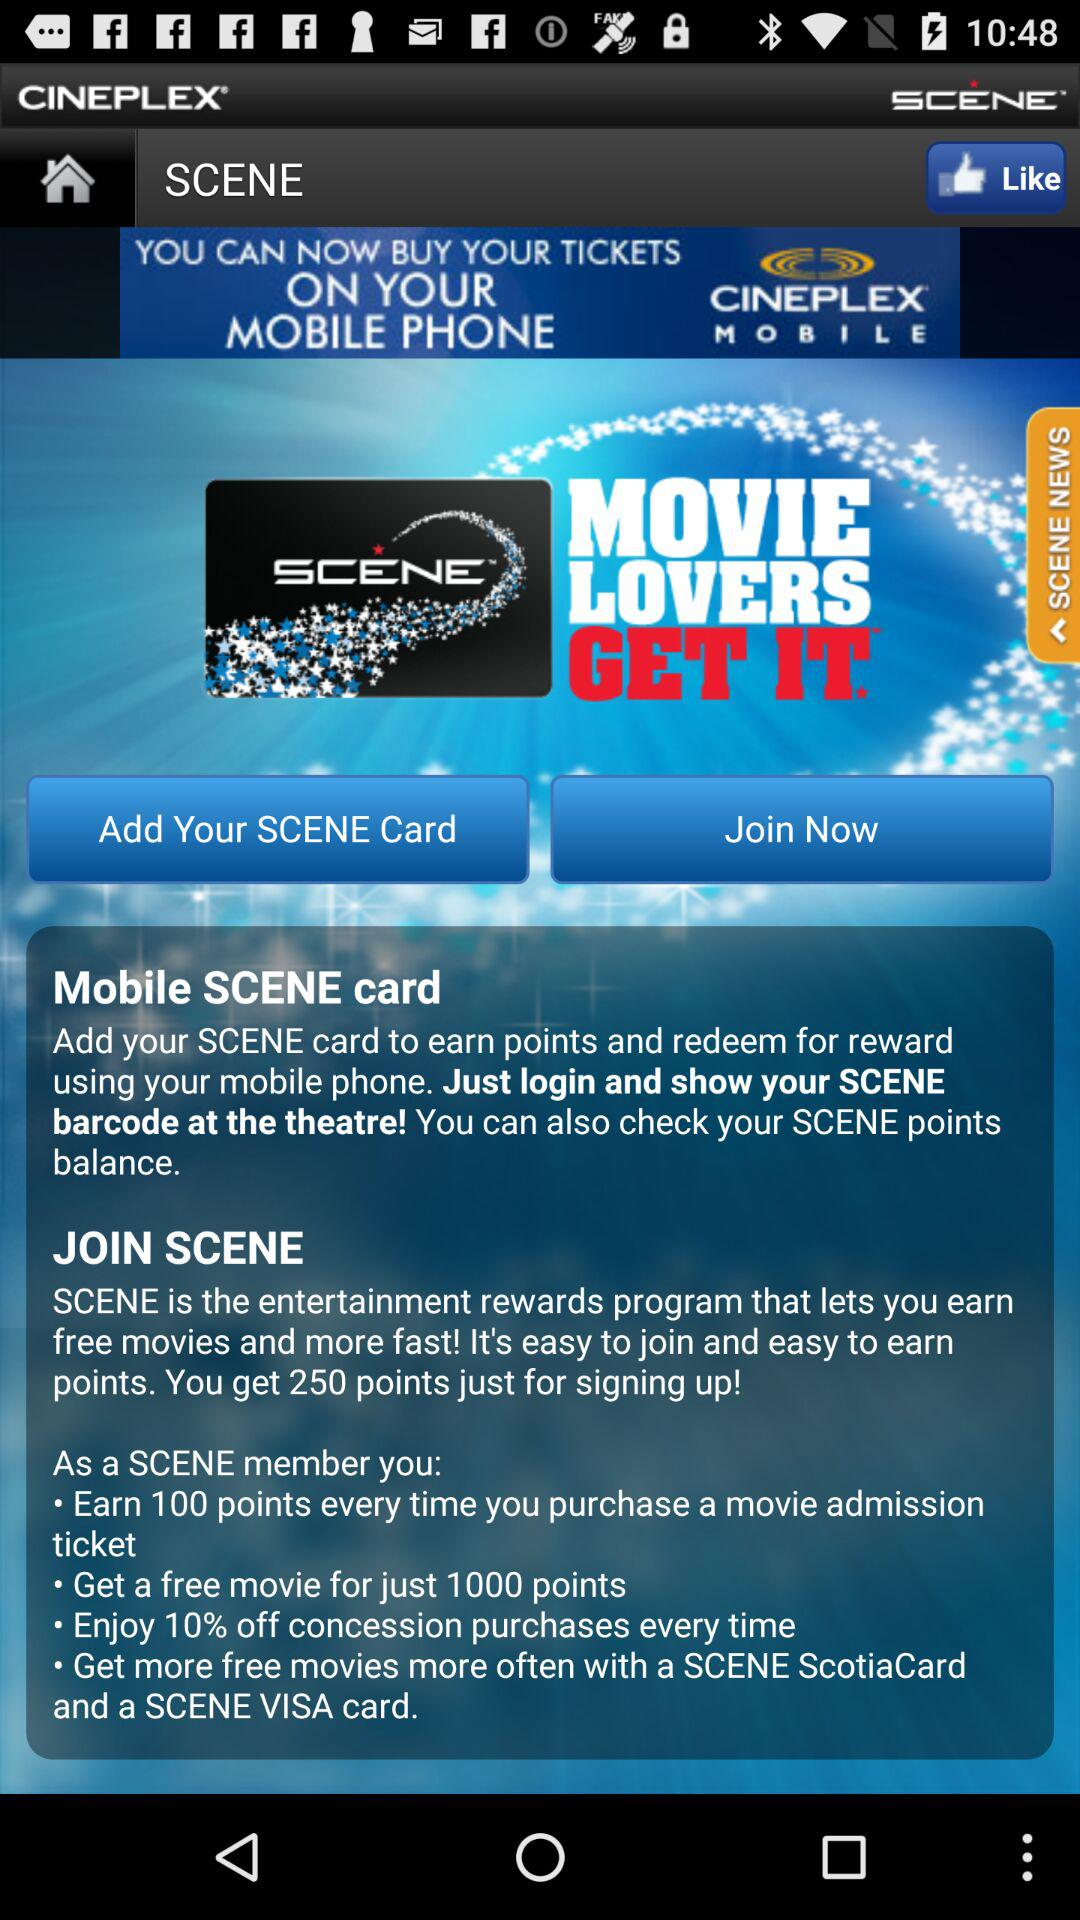What is the percentage of the concession on purchase? The concession on purchase is 10%. 